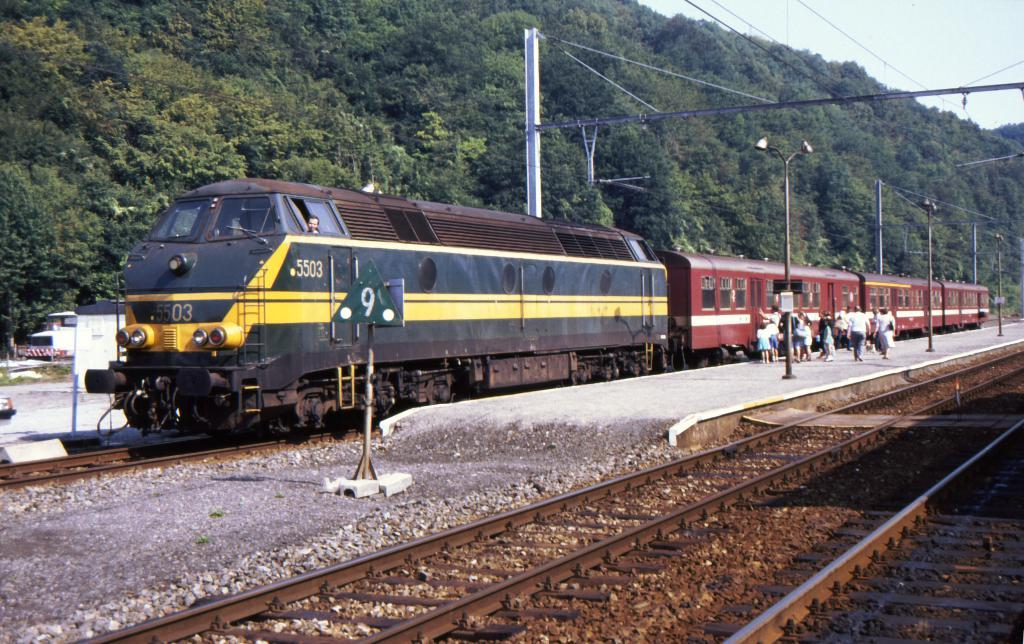<image>
Summarize the visual content of the image. Train number 5503 is stopped on track number 9. 